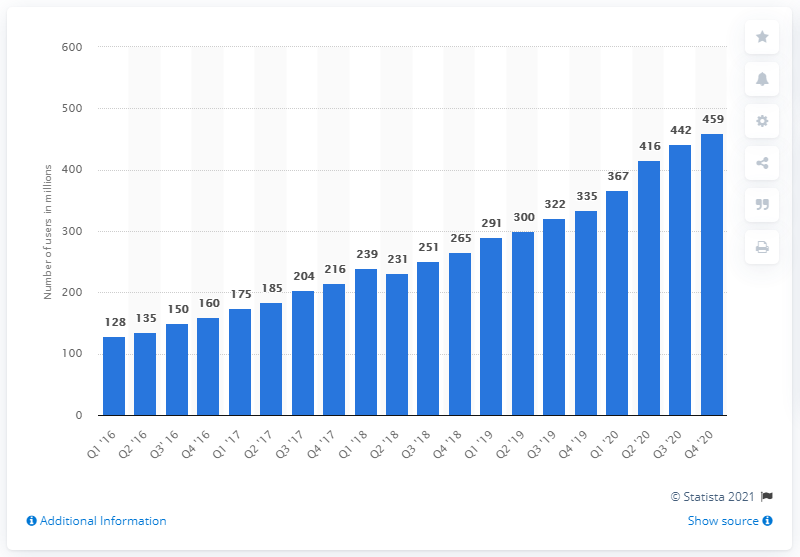Identify some key points in this picture. As of the fourth quarter of 2020, Pinterest had approximately 459 monthly active users worldwide. 